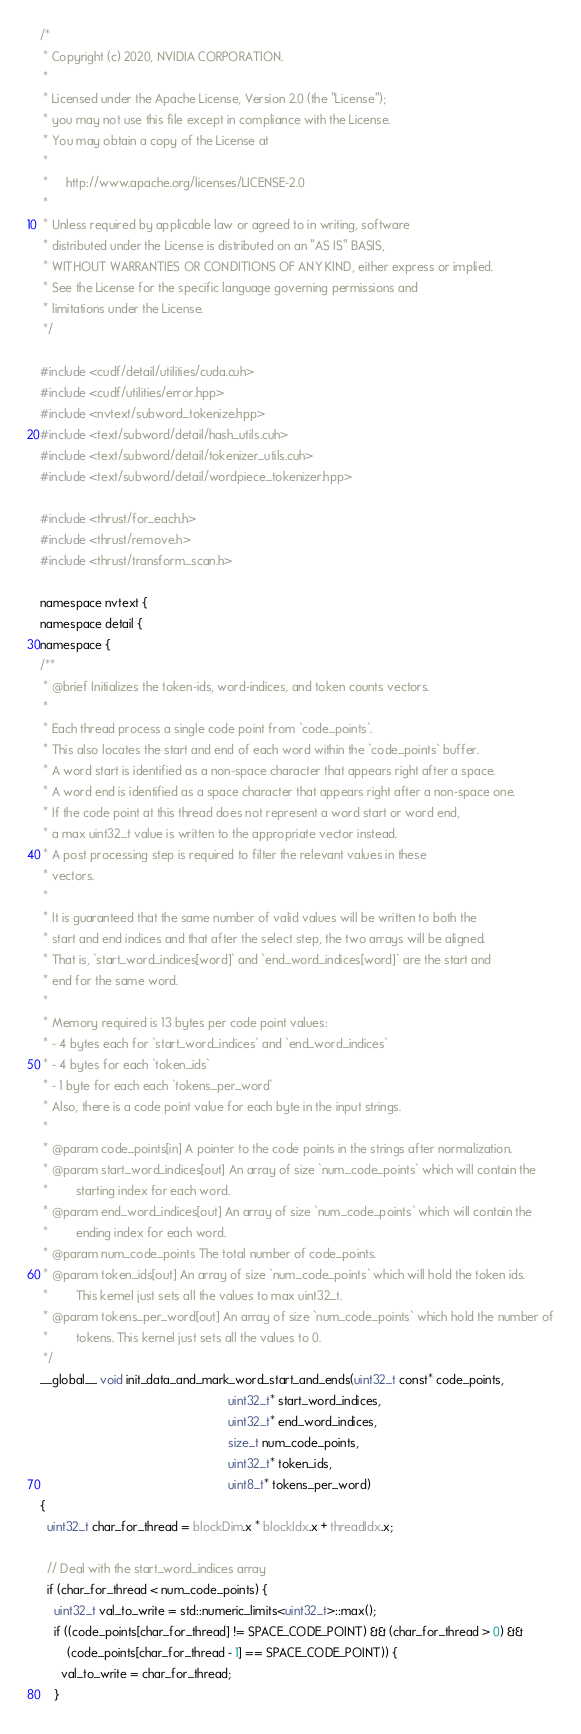Convert code to text. <code><loc_0><loc_0><loc_500><loc_500><_Cuda_>/*
 * Copyright (c) 2020, NVIDIA CORPORATION.
 *
 * Licensed under the Apache License, Version 2.0 (the "License");
 * you may not use this file except in compliance with the License.
 * You may obtain a copy of the License at
 *
 *     http://www.apache.org/licenses/LICENSE-2.0
 *
 * Unless required by applicable law or agreed to in writing, software
 * distributed under the License is distributed on an "AS IS" BASIS,
 * WITHOUT WARRANTIES OR CONDITIONS OF ANY KIND, either express or implied.
 * See the License for the specific language governing permissions and
 * limitations under the License.
 */

#include <cudf/detail/utilities/cuda.cuh>
#include <cudf/utilities/error.hpp>
#include <nvtext/subword_tokenize.hpp>
#include <text/subword/detail/hash_utils.cuh>
#include <text/subword/detail/tokenizer_utils.cuh>
#include <text/subword/detail/wordpiece_tokenizer.hpp>

#include <thrust/for_each.h>
#include <thrust/remove.h>
#include <thrust/transform_scan.h>

namespace nvtext {
namespace detail {
namespace {
/**
 * @brief Initializes the token-ids, word-indices, and token counts vectors.
 *
 * Each thread process a single code point from `code_points`.
 * This also locates the start and end of each word within the `code_points` buffer.
 * A word start is identified as a non-space character that appears right after a space.
 * A word end is identified as a space character that appears right after a non-space one.
 * If the code point at this thread does not represent a word start or word end,
 * a max uint32_t value is written to the appropriate vector instead.
 * A post processing step is required to filter the relevant values in these
 * vectors.
 *
 * It is guaranteed that the same number of valid values will be written to both the
 * start and end indices and that after the select step, the two arrays will be aligned.
 * That is, `start_word_indices[word]` and `end_word_indices[word]` are the start and
 * end for the same word.
 *
 * Memory required is 13 bytes per code point values:
 * - 4 bytes each for `start_word_indices` and `end_word_indices`
 * - 4 bytes for each `token_ids`
 * - 1 byte for each each `tokens_per_word`
 * Also, there is a code point value for each byte in the input strings.
 *
 * @param code_points[in] A pointer to the code points in the strings after normalization.
 * @param start_word_indices[out] An array of size `num_code_points` which will contain the
 *        starting index for each word.
 * @param end_word_indices[out] An array of size `num_code_points` which will contain the
 *        ending index for each word.
 * @param num_code_points The total number of code_points.
 * @param token_ids[out] An array of size `num_code_points` which will hold the token ids.
 *        This kernel just sets all the values to max uint32_t.
 * @param tokens_per_word[out] An array of size `num_code_points` which hold the number of
 *        tokens. This kernel just sets all the values to 0.
 */
__global__ void init_data_and_mark_word_start_and_ends(uint32_t const* code_points,
                                                       uint32_t* start_word_indices,
                                                       uint32_t* end_word_indices,
                                                       size_t num_code_points,
                                                       uint32_t* token_ids,
                                                       uint8_t* tokens_per_word)
{
  uint32_t char_for_thread = blockDim.x * blockIdx.x + threadIdx.x;

  // Deal with the start_word_indices array
  if (char_for_thread < num_code_points) {
    uint32_t val_to_write = std::numeric_limits<uint32_t>::max();
    if ((code_points[char_for_thread] != SPACE_CODE_POINT) && (char_for_thread > 0) &&
        (code_points[char_for_thread - 1] == SPACE_CODE_POINT)) {
      val_to_write = char_for_thread;
    }</code> 